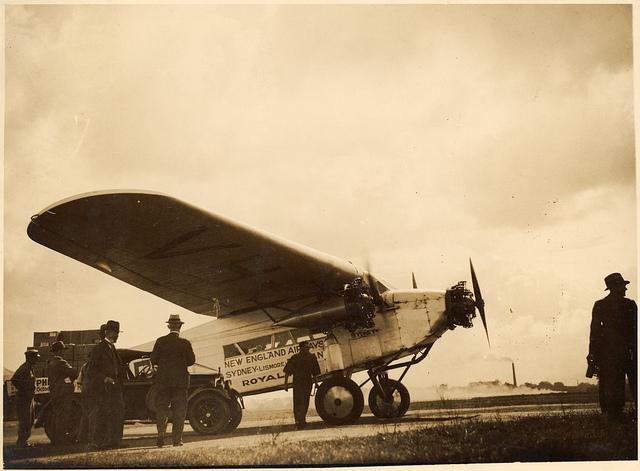Is this a jet plane?
Answer briefly. No. How do you know this is a vintage photo?
Quick response, please. Sepia. Is the sky clear?
Write a very short answer. No. Is this a modern plane?
Be succinct. No. Do you see any wheels?
Write a very short answer. Yes. What is the plane sitting next to?
Write a very short answer. Car. How many vehicles are shown?
Short answer required. 2. 